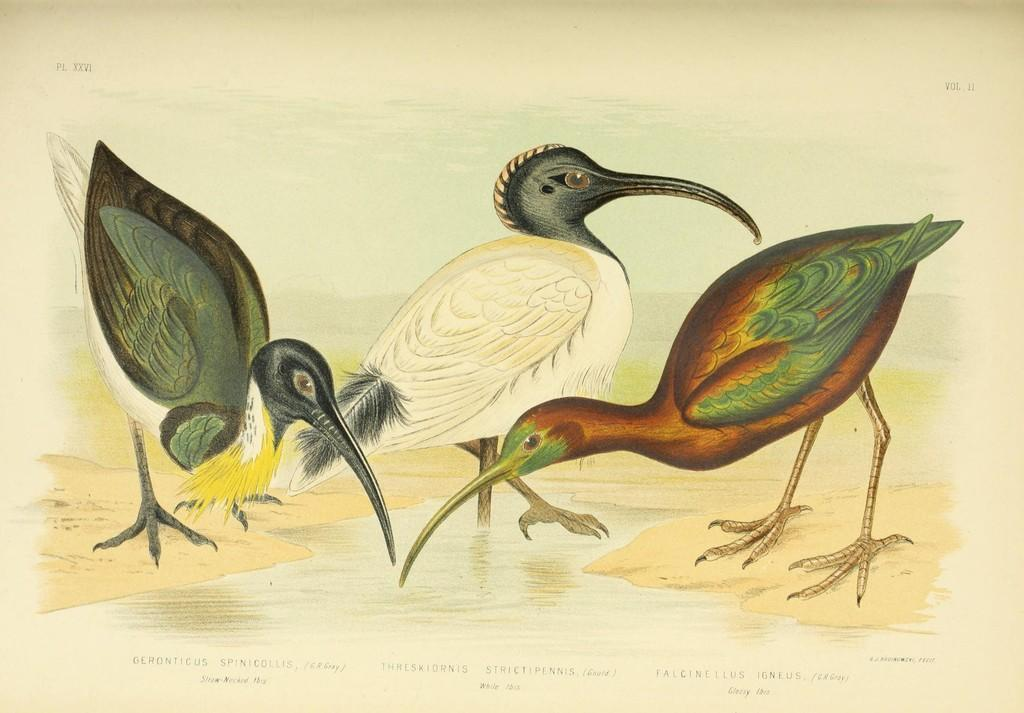What type of artwork is the image? The image is a painting. What animals are present in the painting? There are birds in the painting. What natural element is depicted in the painting? There is water depicted in the painting. What type of swing can be seen in the painting? There is no swing present in the painting; it features birds and water. What appliance is depicted in the painting? There are no appliances depicted in the painting; it features birds and water. 